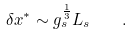<formula> <loc_0><loc_0><loc_500><loc_500>\delta x ^ { \ast } \sim g _ { s } ^ { \frac { 1 } { 3 } } L _ { s } \quad .</formula> 